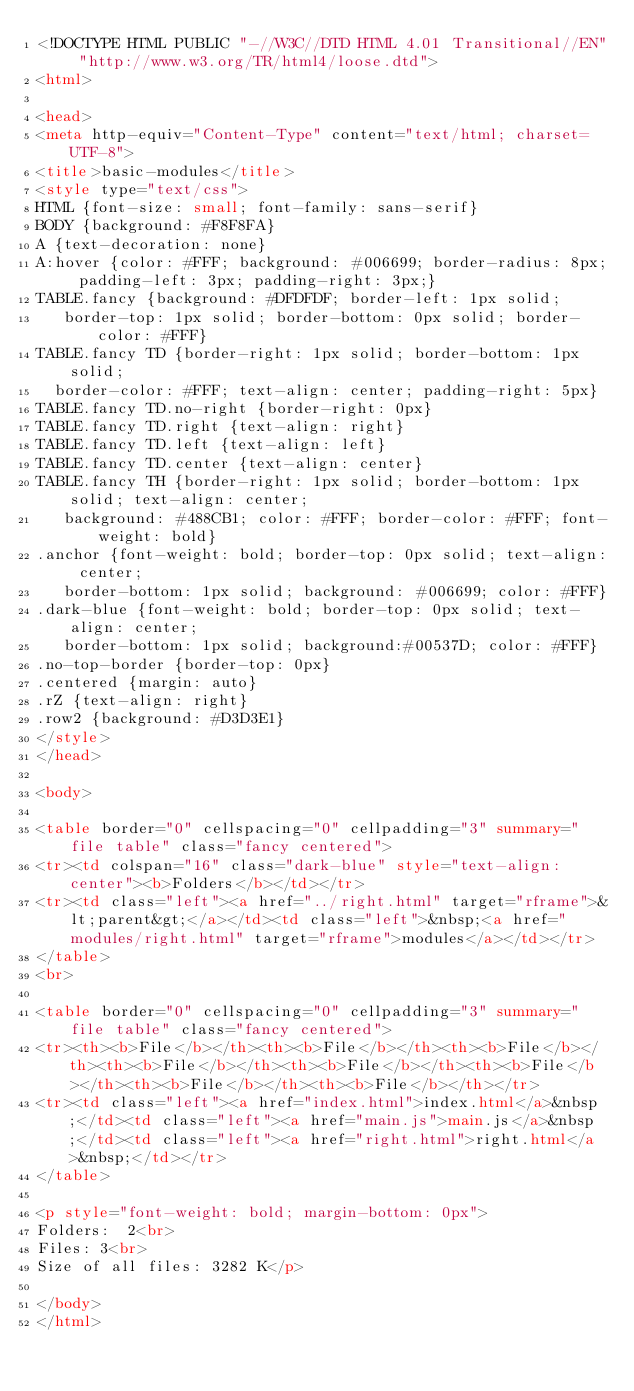Convert code to text. <code><loc_0><loc_0><loc_500><loc_500><_HTML_><!DOCTYPE HTML PUBLIC "-//W3C//DTD HTML 4.01 Transitional//EN" "http://www.w3.org/TR/html4/loose.dtd">
<html>

<head>
<meta http-equiv="Content-Type" content="text/html; charset=UTF-8">
<title>basic-modules</title>
<style type="text/css">
HTML {font-size: small; font-family: sans-serif}
BODY {background: #F8F8FA}
A {text-decoration: none}
A:hover {color: #FFF; background: #006699; border-radius: 8px; padding-left: 3px; padding-right: 3px;}
TABLE.fancy {background: #DFDFDF; border-left: 1px solid;
   border-top: 1px solid; border-bottom: 0px solid; border-color: #FFF}
TABLE.fancy TD {border-right: 1px solid; border-bottom: 1px solid;
  border-color: #FFF; text-align: center; padding-right: 5px}
TABLE.fancy TD.no-right {border-right: 0px}
TABLE.fancy TD.right {text-align: right}
TABLE.fancy TD.left {text-align: left}
TABLE.fancy TD.center {text-align: center}
TABLE.fancy TH {border-right: 1px solid; border-bottom: 1px solid; text-align: center;
   background: #488CB1; color: #FFF; border-color: #FFF; font-weight: bold}
.anchor {font-weight: bold; border-top: 0px solid; text-align: center;
   border-bottom: 1px solid; background: #006699; color: #FFF}
.dark-blue {font-weight: bold; border-top: 0px solid; text-align: center;
   border-bottom: 1px solid; background:#00537D; color: #FFF}
.no-top-border {border-top: 0px}
.centered {margin: auto}
.rZ {text-align: right}
.row2 {background: #D3D3E1}
</style>
</head>

<body>

<table border="0" cellspacing="0" cellpadding="3" summary="file table" class="fancy centered">
<tr><td colspan="16" class="dark-blue" style="text-align: center"><b>Folders</b></td></tr>
<tr><td class="left"><a href="../right.html" target="rframe">&lt;parent&gt;</a></td><td class="left">&nbsp;<a href="modules/right.html" target="rframe">modules</a></td></tr>
</table>
<br>

<table border="0" cellspacing="0" cellpadding="3" summary="file table" class="fancy centered">
<tr><th><b>File</b></th><th><b>File</b></th><th><b>File</b></th><th><b>File</b></th><th><b>File</b></th><th><b>File</b></th><th><b>File</b></th><th><b>File</b></th></tr>
<tr><td class="left"><a href="index.html">index.html</a>&nbsp;</td><td class="left"><a href="main.js">main.js</a>&nbsp;</td><td class="left"><a href="right.html">right.html</a>&nbsp;</td></tr>
</table>

<p style="font-weight: bold; margin-bottom: 0px">
Folders:  2<br>
Files: 3<br>
Size of all files: 3282 K</p>

</body>
</html></code> 